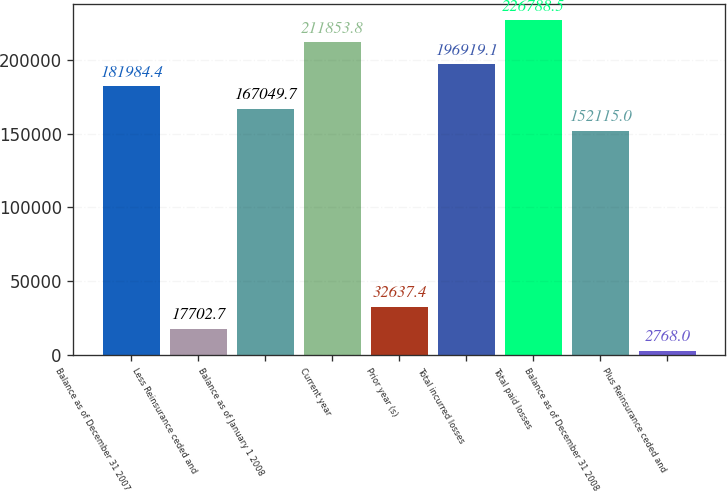Convert chart. <chart><loc_0><loc_0><loc_500><loc_500><bar_chart><fcel>Balance as of December 31 2007<fcel>Less Reinsurance ceded and<fcel>Balance as of January 1 2008<fcel>Current year<fcel>Prior year (s)<fcel>Total incurred losses<fcel>Total paid losses<fcel>Balance as of December 31 2008<fcel>Plus Reinsurance ceded and<nl><fcel>181984<fcel>17702.7<fcel>167050<fcel>211854<fcel>32637.4<fcel>196919<fcel>226788<fcel>152115<fcel>2768<nl></chart> 